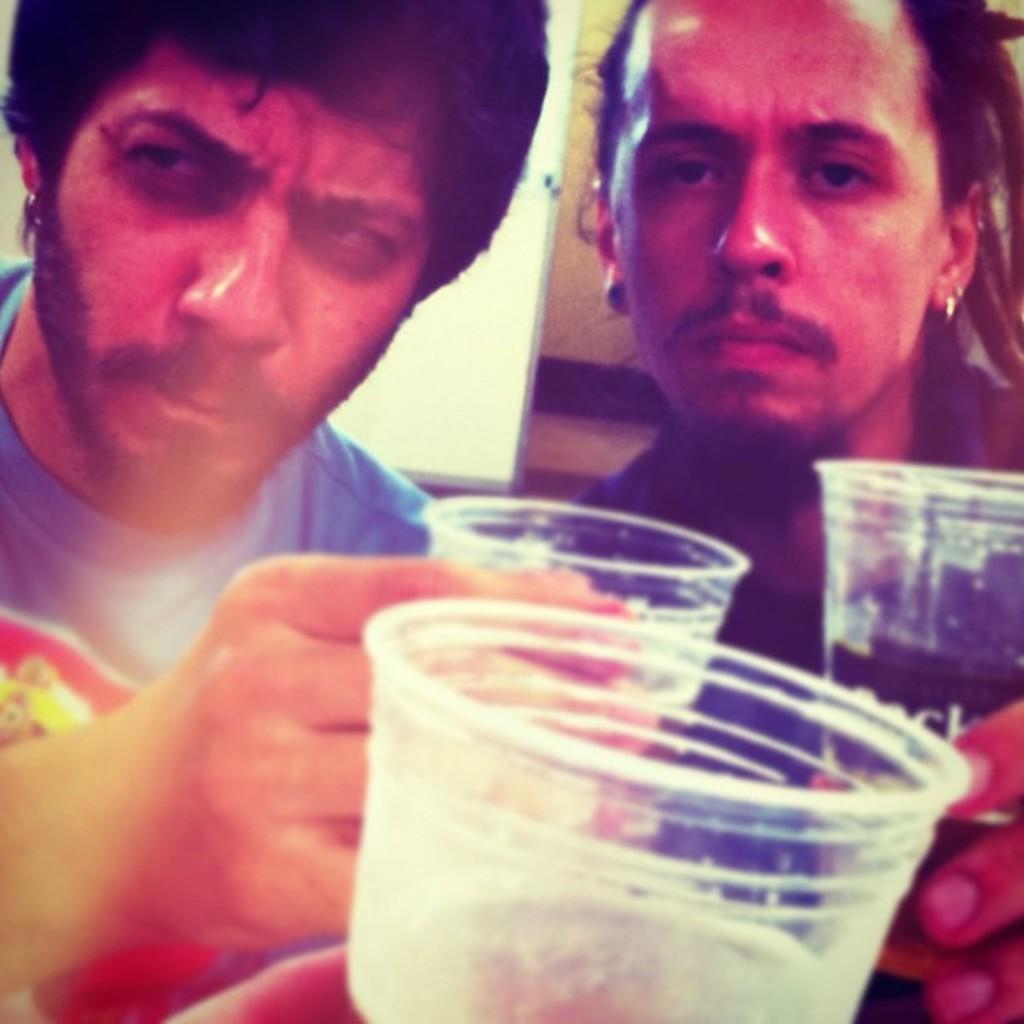How many people are in the image? There are two persons in the image. What objects can be seen in the image besides the people? There are three glasses in the image. What are the glasses doing in the image? The glasses are clinking together. What type of scarecrow can be seen in the image? There is no scarecrow present in the image. How does the belief system of the people in the image affect their actions? The provided facts do not give any information about the belief system of the people in the image, so we cannot determine how it affects their actions. 